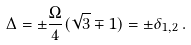Convert formula to latex. <formula><loc_0><loc_0><loc_500><loc_500>\Delta = \pm \frac { \Omega } { 4 } ( \sqrt { 3 } \mp 1 ) = \pm \delta _ { 1 , 2 } \, .</formula> 